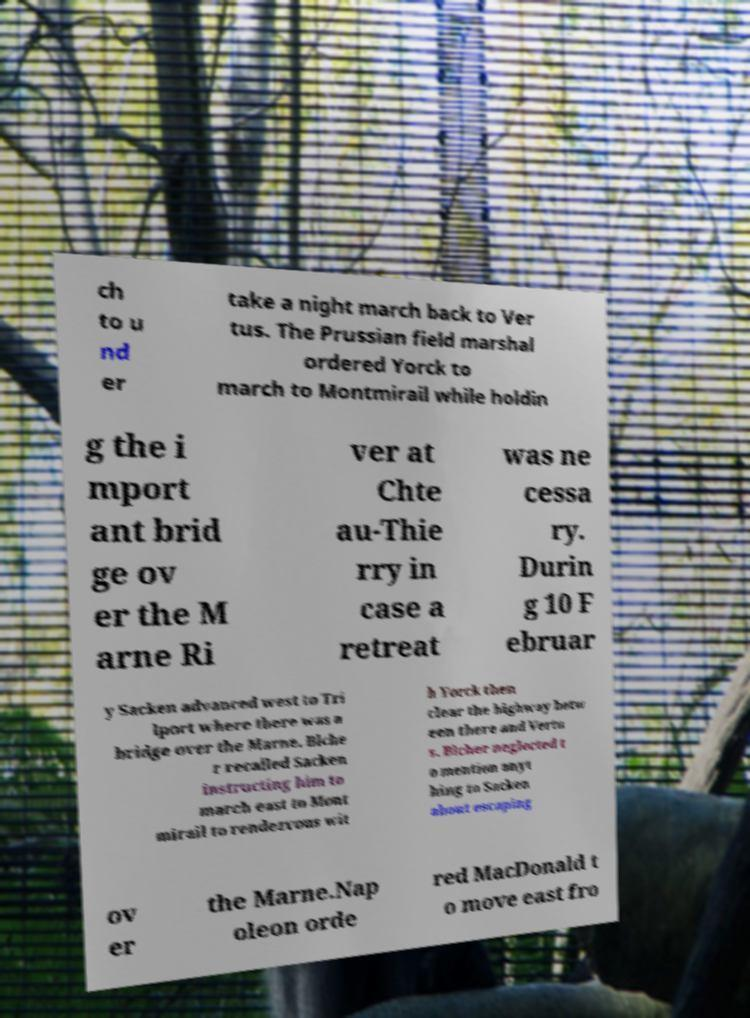Please read and relay the text visible in this image. What does it say? ch to u nd er take a night march back to Ver tus. The Prussian field marshal ordered Yorck to march to Montmirail while holdin g the i mport ant brid ge ov er the M arne Ri ver at Chte au-Thie rry in case a retreat was ne cessa ry. Durin g 10 F ebruar y Sacken advanced west to Tri lport where there was a bridge over the Marne. Blche r recalled Sacken instructing him to march east to Mont mirail to rendezvous wit h Yorck then clear the highway betw een there and Vertu s. Blcher neglected t o mention anyt hing to Sacken about escaping ov er the Marne.Nap oleon orde red MacDonald t o move east fro 